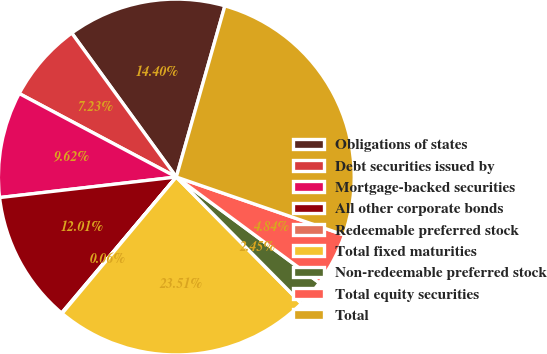Convert chart. <chart><loc_0><loc_0><loc_500><loc_500><pie_chart><fcel>Obligations of states<fcel>Debt securities issued by<fcel>Mortgage-backed securities<fcel>All other corporate bonds<fcel>Redeemable preferred stock<fcel>Total fixed maturities<fcel>Non-redeemable preferred stock<fcel>Total equity securities<fcel>Total<nl><fcel>14.4%<fcel>7.23%<fcel>9.62%<fcel>12.01%<fcel>0.06%<fcel>23.51%<fcel>2.45%<fcel>4.84%<fcel>25.9%<nl></chart> 